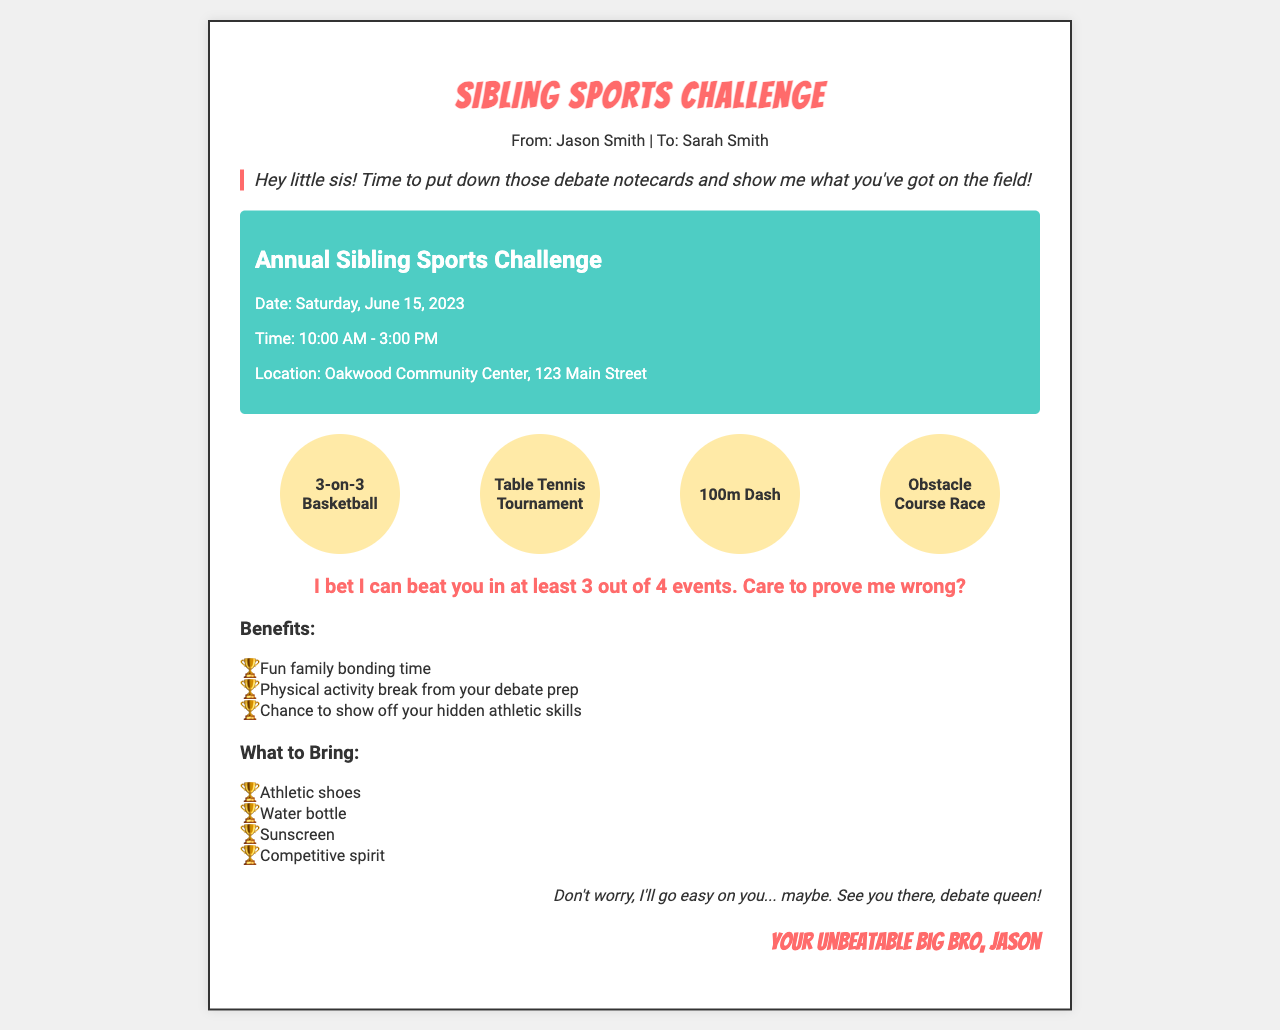What is the date of the event? The date of the event is explicitly mentioned in the document as Saturday, June 15, 2023.
Answer: Saturday, June 15, 2023 What is the location of the event? The document clearly states the location as Oakwood Community Center, 123 Main Street.
Answer: Oakwood Community Center, 123 Main Street Who is the sender of the fax? The sender is identified as Jason Smith in the header of the document.
Answer: Jason Smith What are the activities listed? The document lists several activities for the event, including 3-on-3 Basketball, Table Tennis Tournament, 100m Dash, and Obstacle Course Race.
Answer: 3-on-3 Basketball, Table Tennis Tournament, 100m Dash, Obstacle Course Race What time does the event start? The start time for the event is mentioned as 10:00 AM in the document.
Answer: 10:00 AM What should participants bring? The document lists items to bring including Athletic shoes, Water bottle, Sunscreen, and Competitive spirit.
Answer: Athletic shoes, Water bottle, Sunscreen, Competitive spirit What is the challenge posed by Jason? Jason challenges Sarah by claiming he can beat her in at least 3 out of 4 events.
Answer: He can beat you in at least 3 out of 4 events What is the tone of the introduction? The tone of the introduction is playful and teasing, as indicated by the phrase "put down those debate notecards."
Answer: Playful and teasing 